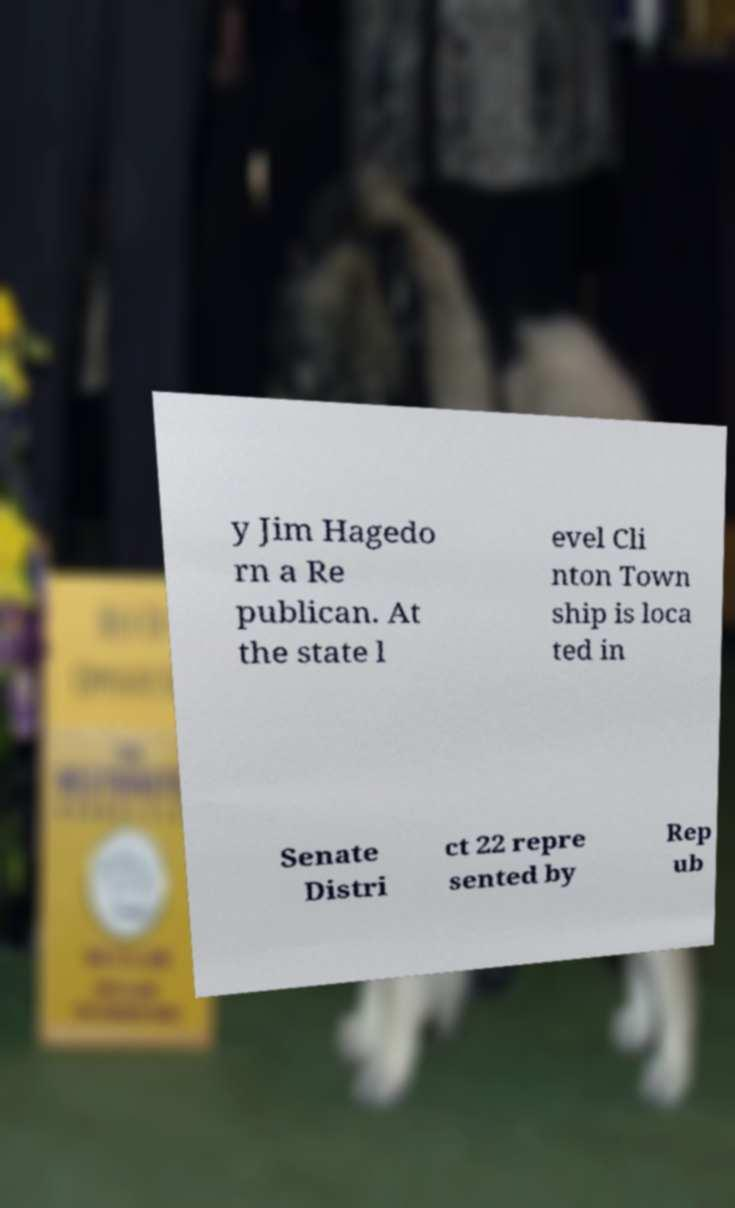Could you assist in decoding the text presented in this image and type it out clearly? y Jim Hagedo rn a Re publican. At the state l evel Cli nton Town ship is loca ted in Senate Distri ct 22 repre sented by Rep ub 